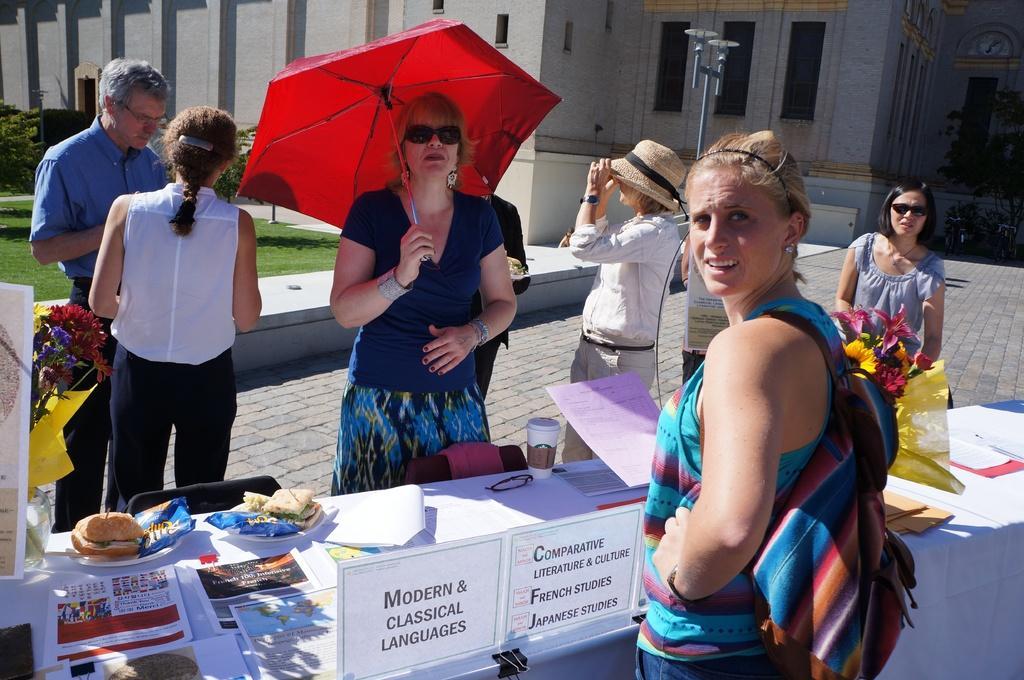In one or two sentences, can you explain what this image depicts? This picture shows a group of women standing and we see some food and papers on the tables and we see two flower vase on the sides and we see a woman holding a umbrella in her hand and we see a building and a woman wore a hat on her head. we see other woman wore a backpack on her back 